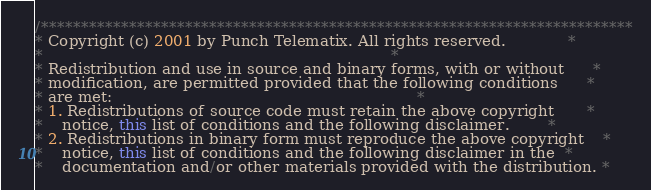Convert code to text. <code><loc_0><loc_0><loc_500><loc_500><_Java_>/**************************************************************************
* Copyright (c) 2001 by Punch Telematix. All rights reserved.             *
*                                                                         *
* Redistribution and use in source and binary forms, with or without      *
* modification, are permitted provided that the following conditions      *
* are met:                                                                *
* 1. Redistributions of source code must retain the above copyright       *
*    notice, this list of conditions and the following disclaimer.        *
* 2. Redistributions in binary form must reproduce the above copyright    *
*    notice, this list of conditions and the following disclaimer in the  *
*    documentation and/or other materials provided with the distribution. *</code> 